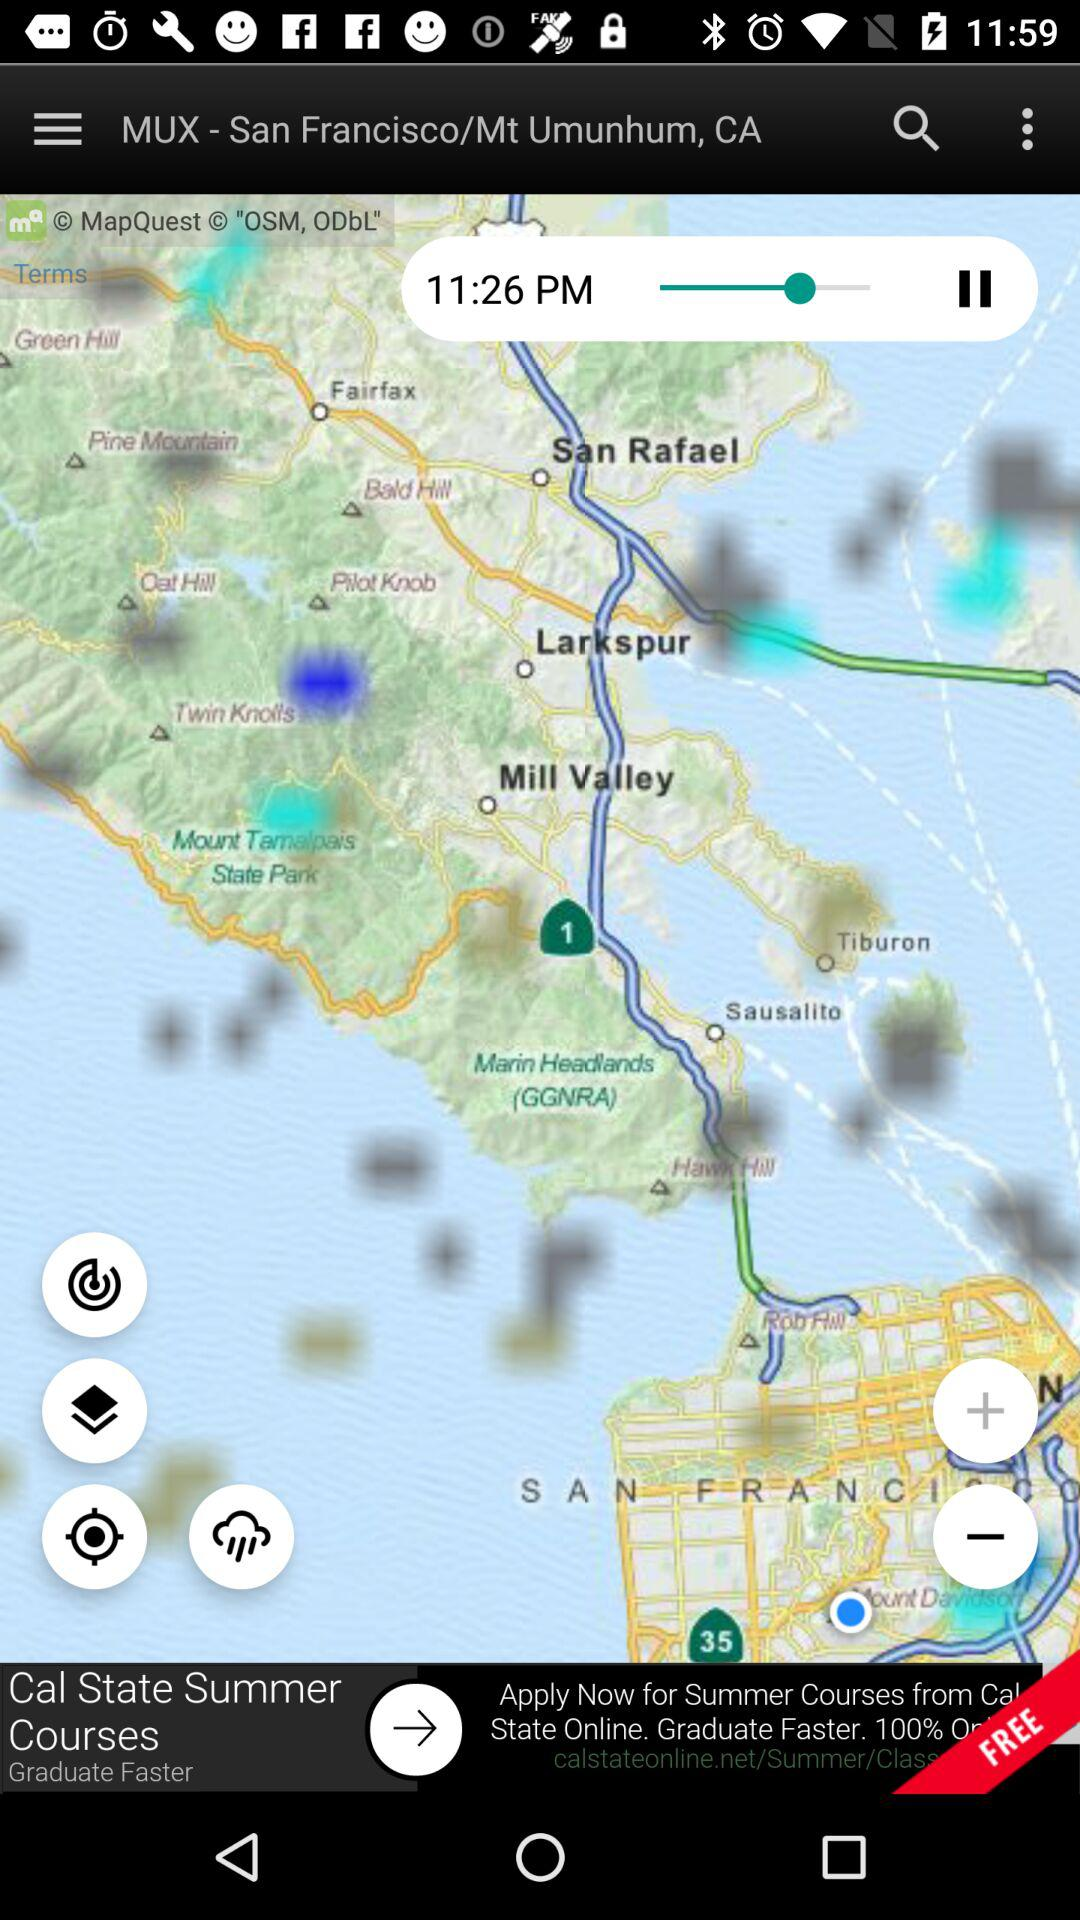What is the shown location? The shown location is "MUX - San Francisco/Mt Umunhum, CA". 